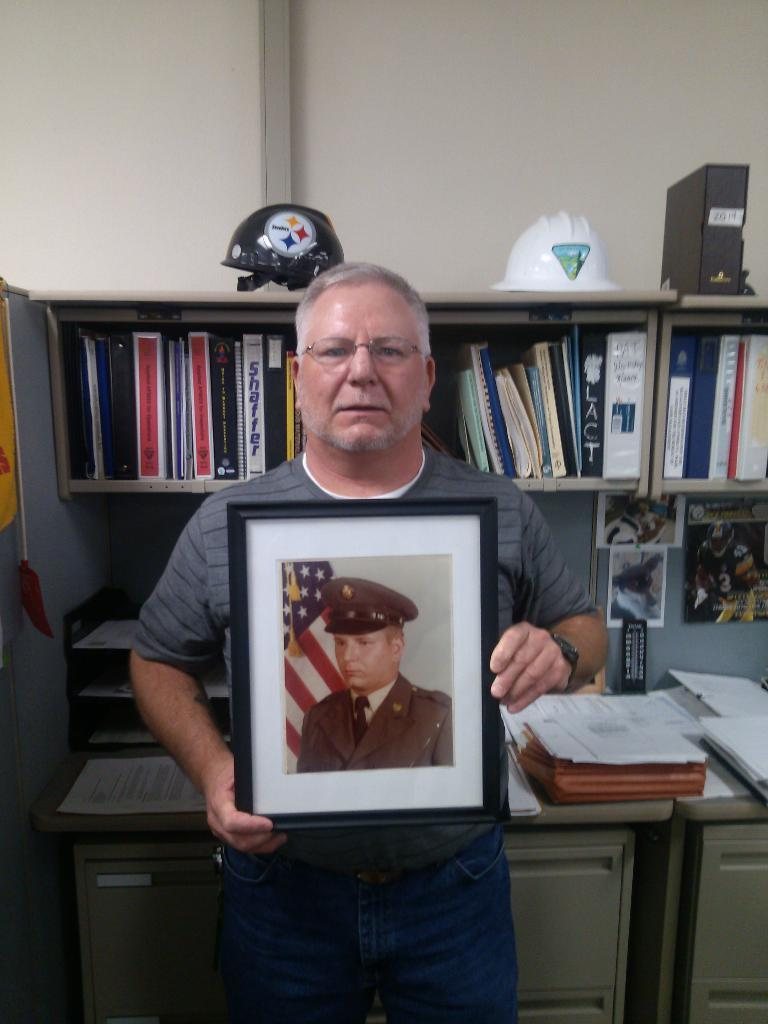What is the main subject of the image? There is a man in the image. What is the man holding in the image? The man is holding a frame with his hands. Can you describe the man's appearance? The man is wearing spectacles. What can be seen in the background of the image? There is a rack with books in the background, and there is also a wall. What type of trail can be seen behind the man in the image? There is no trail visible behind the man in the image. Is there a parcel being delivered to the man in the image? There is no parcel present in the image. 